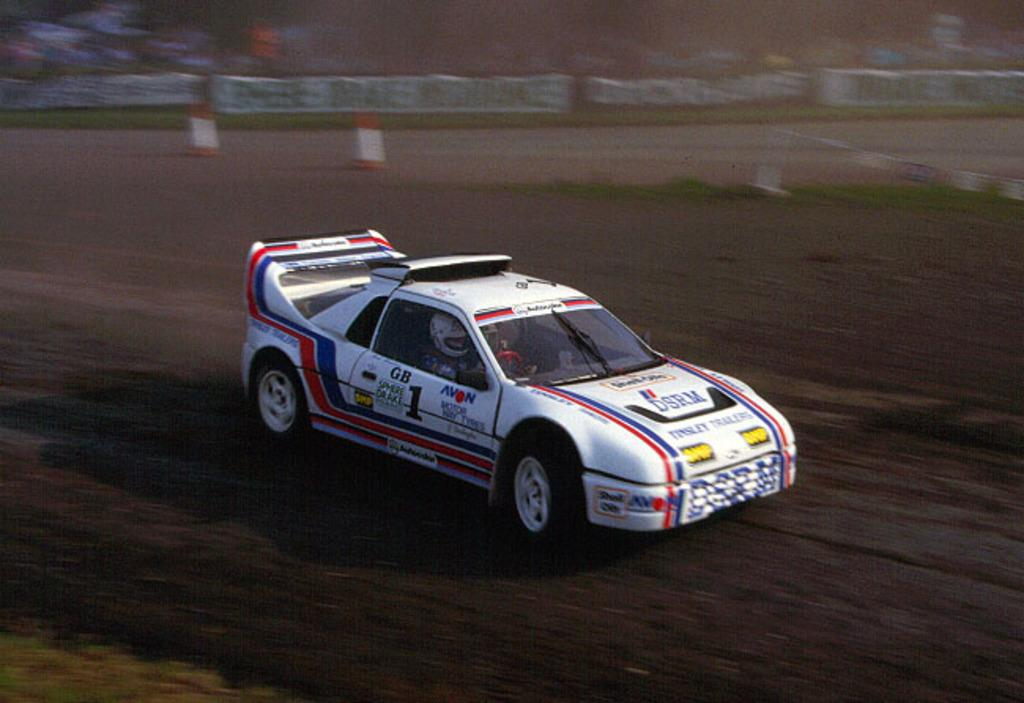What is happening in the image? There is a person in the image who is riding a vehicle. Can you describe the vehicle? Unfortunately, the specific details of the vehicle cannot be determined from the image. What is visible behind the vehicle? There is fencing behind the vehicle. How would you describe the background of the image? The background of the image is blurred. How many dimes can be seen on the desk in the image? There is no desk or dimes present in the image. Can you describe the visitor in the image? There is no visitor mentioned in the provided facts, and the image only shows a person riding a vehicle. 